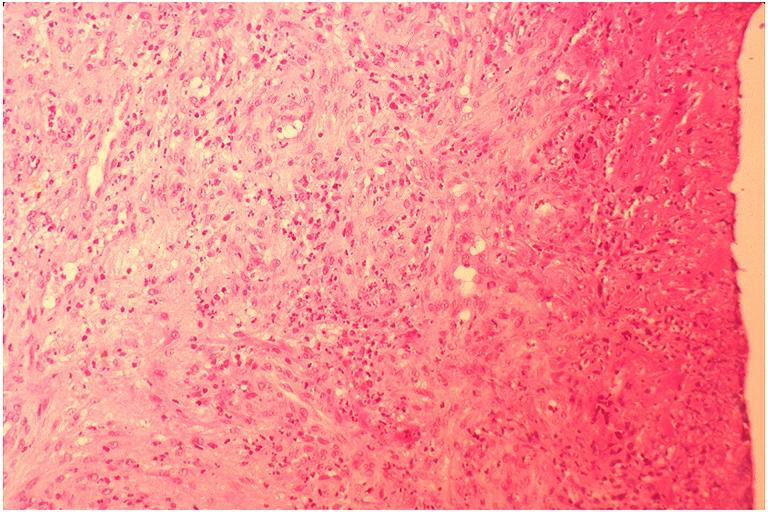what does this image show?
Answer the question using a single word or phrase. Pyogenic granuloma 